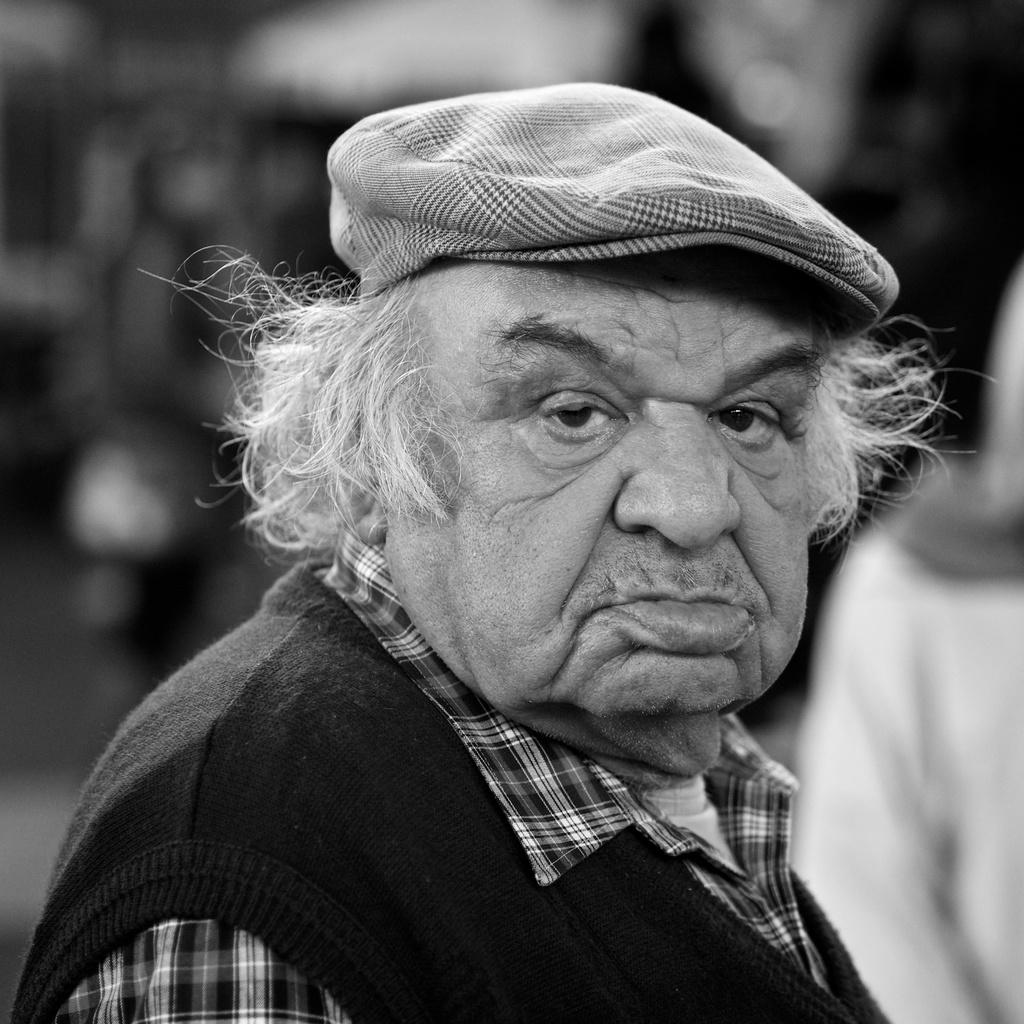Who or what is the main subject of the image? There is a person in the image. What is the person wearing on their head? The person is wearing a cap. Can you describe the background of the image? The background of the image is blurred. What color scheme is used in the image? The image is in black and white. Reasoning: Let's think step by breaking down the conversation step by step. We start by identifying the main subject of the image, which is the person. Then, we describe the person's attire, specifically mentioning the cap they are wearing. Next, we describe the background of the image, noting that it is blurred. Finally, we mention the color scheme of the image, which is black and white. Absurd Question/Answer: What type of oven can be seen in the image? There is no oven present in the image. How many additional people can be seen in the image? The image only features one person, so there are no other people visible. 